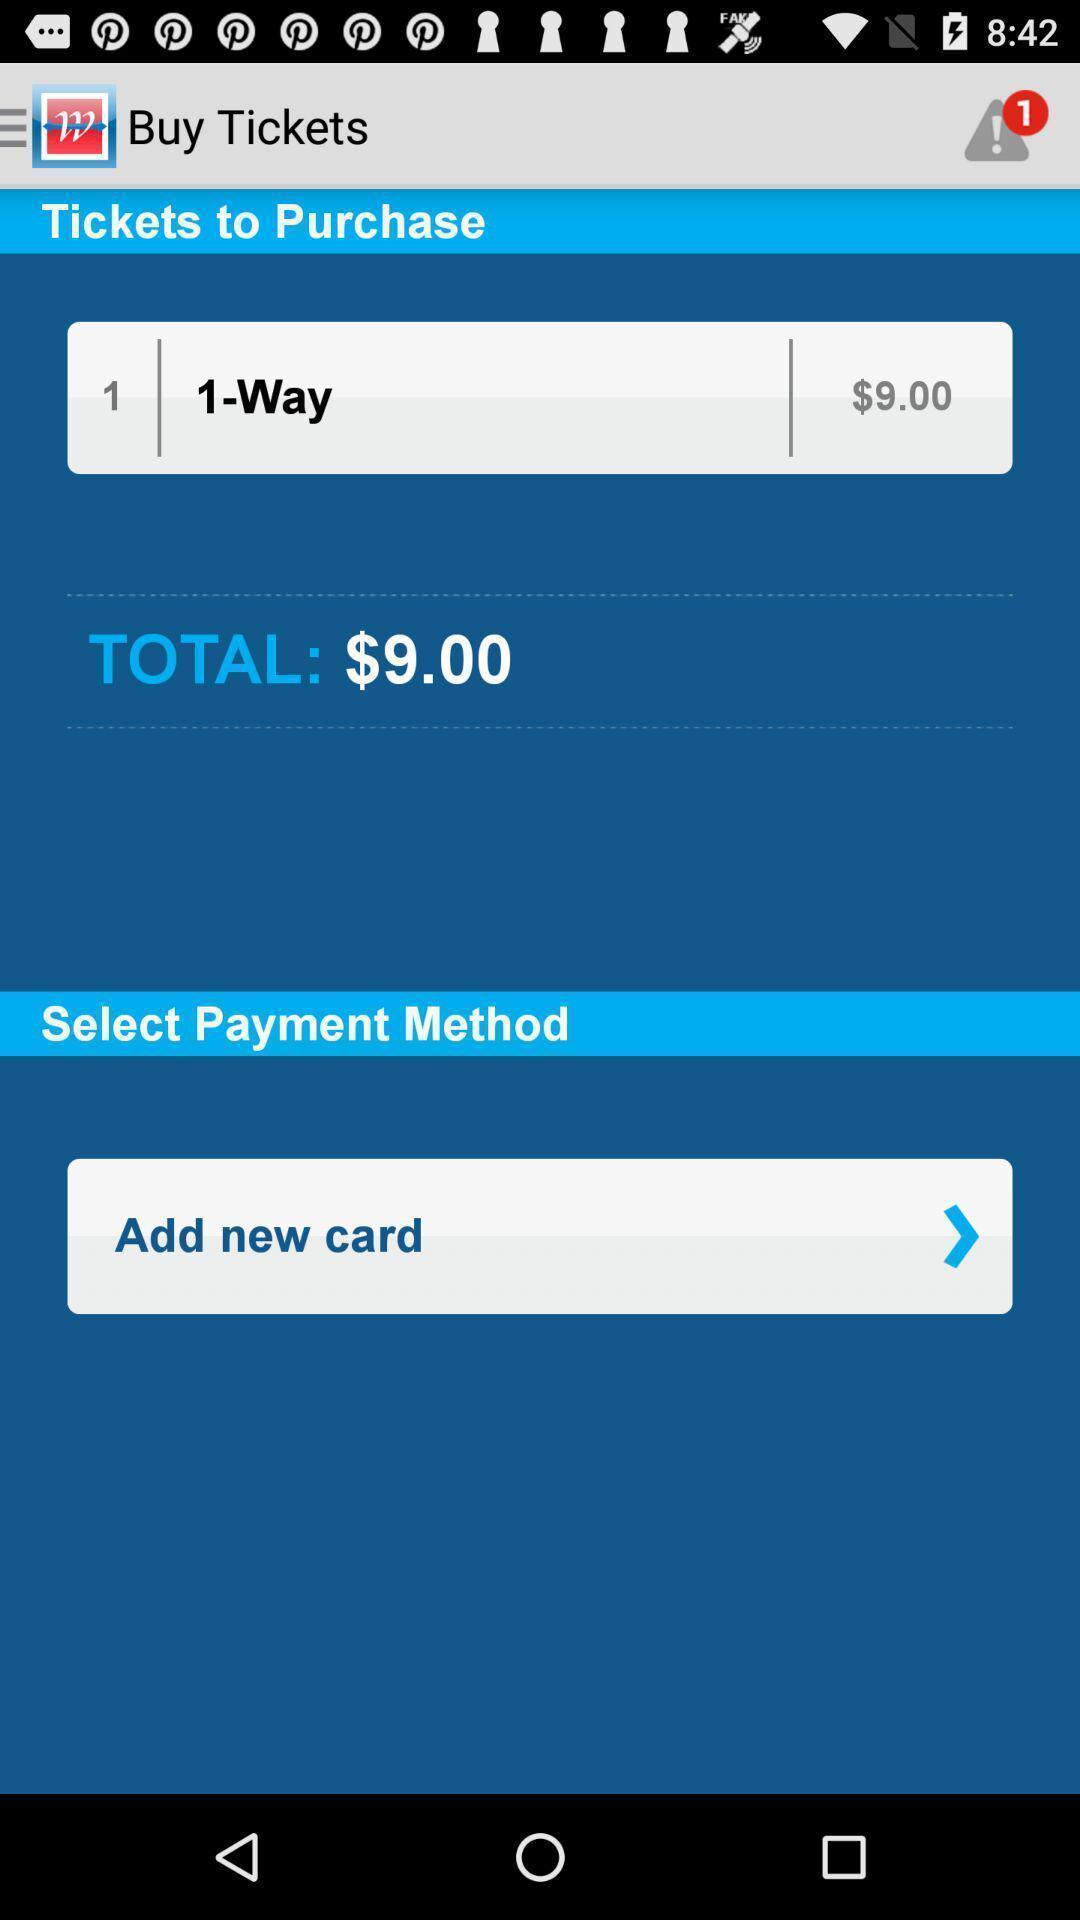Give me a narrative description of this picture. Page with options to buy tickets by selecting payment method. 